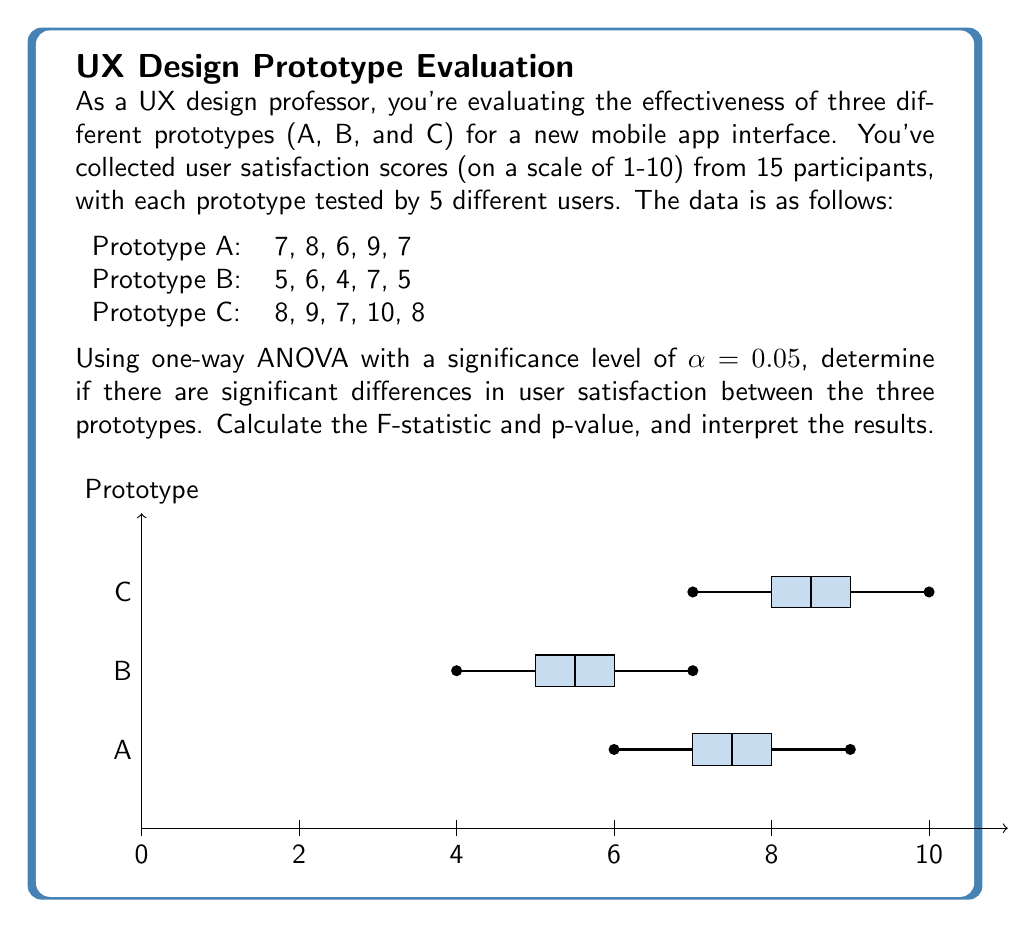Show me your answer to this math problem. Let's solve this problem step by step using one-way ANOVA:

1) First, calculate the means for each group:
   $$\bar{X}_A = \frac{7+8+6+9+7}{5} = 7.4$$
   $$\bar{X}_B = \frac{5+6+4+7+5}{5} = 5.4$$
   $$\bar{X}_C = \frac{8+9+7+10+8}{5} = 8.4$$

2) Calculate the grand mean:
   $$\bar{X} = \frac{7.4 + 5.4 + 8.4}{3} = 7.0667$$

3) Calculate the Sum of Squares Between groups (SSB):
   $$SSB = 5[(7.4-7.0667)^2 + (5.4-7.0667)^2 + (8.4-7.0667)^2] = 22.5333$$

4) Calculate the Sum of Squares Within groups (SSW):
   $$SSW = \sum_{i=1}^{3}\sum_{j=1}^{5}(X_{ij}-\bar{X}_i)^2 = 14$$

5) Calculate the Sum of Squares Total (SST):
   $$SST = SSB + SSW = 22.5333 + 14 = 36.5333$$

6) Calculate degrees of freedom:
   $$df_{between} = k - 1 = 3 - 1 = 2$$
   $$df_{within} = N - k = 15 - 3 = 12$$
   $$df_{total} = N - 1 = 15 - 1 = 14$$

7) Calculate Mean Square Between (MSB) and Mean Square Within (MSW):
   $$MSB = \frac{SSB}{df_{between}} = \frac{22.5333}{2} = 11.2667$$
   $$MSW = \frac{SSW}{df_{within}} = \frac{14}{12} = 1.1667$$

8) Calculate the F-statistic:
   $$F = \frac{MSB}{MSW} = \frac{11.2667}{1.1667} = 9.6571$$

9) Find the critical F-value:
   For α = 0.05, df₁ = 2, df₂ = 12, F_crit = 3.8853

10) Calculate the p-value:
    Using an F-distribution calculator, we find p-value ≈ 0.0031

11) Interpret the results:
    Since F (9.6571) > F_crit (3.8853) and p-value (0.0031) < α (0.05), we reject the null hypothesis.
Answer: F(2,12) = 9.6571, p = 0.0031. Significant differences exist between prototypes. 